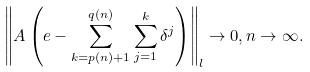<formula> <loc_0><loc_0><loc_500><loc_500>\left \| A \left ( e - \sum _ { k = p ( n ) + 1 } ^ { q ( n ) } \sum _ { j = 1 } ^ { k } \delta ^ { j } \right ) \right \| _ { l } \to 0 , n \to \infty .</formula> 